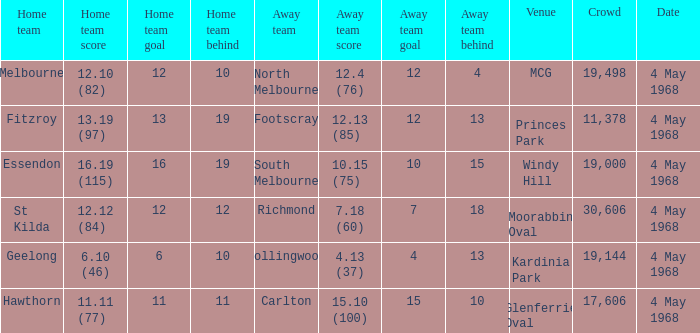How big was the crowd of the team that scored 4.13 (37)? 19144.0. 